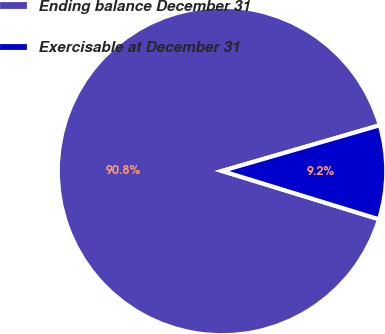Convert chart. <chart><loc_0><loc_0><loc_500><loc_500><pie_chart><fcel>Ending balance December 31<fcel>Exercisable at December 31<nl><fcel>90.76%<fcel>9.24%<nl></chart> 